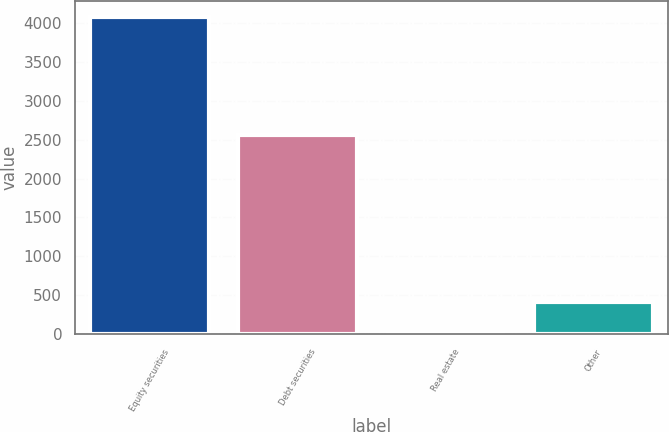Convert chart. <chart><loc_0><loc_0><loc_500><loc_500><bar_chart><fcel>Equity securities<fcel>Debt securities<fcel>Real estate<fcel>Other<nl><fcel>4075<fcel>2560<fcel>10<fcel>416.5<nl></chart> 